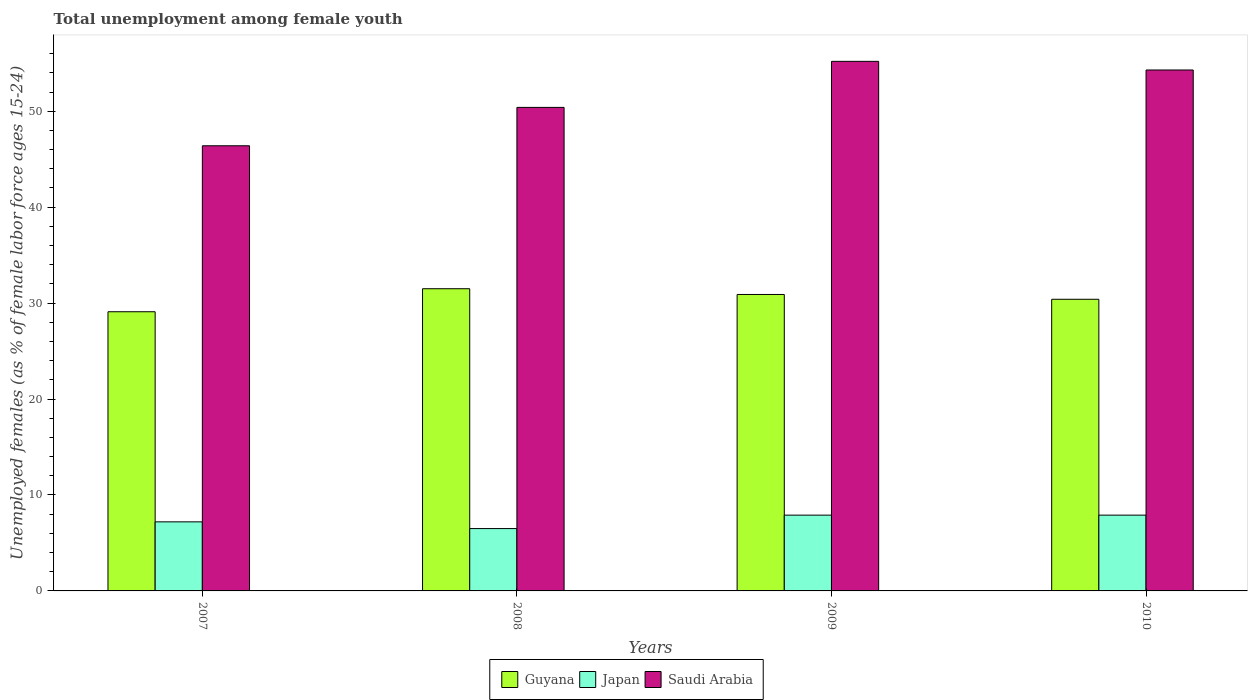How many different coloured bars are there?
Offer a very short reply. 3. How many groups of bars are there?
Make the answer very short. 4. Are the number of bars per tick equal to the number of legend labels?
Provide a short and direct response. Yes. Are the number of bars on each tick of the X-axis equal?
Your answer should be very brief. Yes. How many bars are there on the 2nd tick from the left?
Make the answer very short. 3. How many bars are there on the 4th tick from the right?
Provide a short and direct response. 3. What is the label of the 4th group of bars from the left?
Provide a succinct answer. 2010. In how many cases, is the number of bars for a given year not equal to the number of legend labels?
Offer a terse response. 0. What is the percentage of unemployed females in in Japan in 2010?
Make the answer very short. 7.9. Across all years, what is the maximum percentage of unemployed females in in Japan?
Offer a very short reply. 7.9. Across all years, what is the minimum percentage of unemployed females in in Japan?
Ensure brevity in your answer.  6.5. In which year was the percentage of unemployed females in in Japan maximum?
Provide a short and direct response. 2009. What is the total percentage of unemployed females in in Guyana in the graph?
Your response must be concise. 121.9. What is the difference between the percentage of unemployed females in in Guyana in 2007 and that in 2009?
Your answer should be compact. -1.8. What is the difference between the percentage of unemployed females in in Japan in 2008 and the percentage of unemployed females in in Guyana in 2009?
Keep it short and to the point. -24.4. What is the average percentage of unemployed females in in Saudi Arabia per year?
Provide a short and direct response. 51.58. In the year 2007, what is the difference between the percentage of unemployed females in in Saudi Arabia and percentage of unemployed females in in Japan?
Keep it short and to the point. 39.2. In how many years, is the percentage of unemployed females in in Japan greater than 42 %?
Your answer should be compact. 0. What is the ratio of the percentage of unemployed females in in Guyana in 2009 to that in 2010?
Your answer should be very brief. 1.02. Is the difference between the percentage of unemployed females in in Saudi Arabia in 2008 and 2010 greater than the difference between the percentage of unemployed females in in Japan in 2008 and 2010?
Your response must be concise. No. What is the difference between the highest and the second highest percentage of unemployed females in in Guyana?
Your answer should be very brief. 0.6. What is the difference between the highest and the lowest percentage of unemployed females in in Japan?
Your answer should be compact. 1.4. In how many years, is the percentage of unemployed females in in Saudi Arabia greater than the average percentage of unemployed females in in Saudi Arabia taken over all years?
Make the answer very short. 2. What does the 1st bar from the left in 2010 represents?
Provide a succinct answer. Guyana. What does the 1st bar from the right in 2007 represents?
Offer a very short reply. Saudi Arabia. Is it the case that in every year, the sum of the percentage of unemployed females in in Guyana and percentage of unemployed females in in Japan is greater than the percentage of unemployed females in in Saudi Arabia?
Your answer should be compact. No. How many years are there in the graph?
Ensure brevity in your answer.  4. What is the difference between two consecutive major ticks on the Y-axis?
Ensure brevity in your answer.  10. Are the values on the major ticks of Y-axis written in scientific E-notation?
Your answer should be compact. No. Does the graph contain any zero values?
Give a very brief answer. No. Does the graph contain grids?
Offer a very short reply. No. What is the title of the graph?
Offer a terse response. Total unemployment among female youth. Does "Jamaica" appear as one of the legend labels in the graph?
Make the answer very short. No. What is the label or title of the X-axis?
Provide a succinct answer. Years. What is the label or title of the Y-axis?
Offer a very short reply. Unemployed females (as % of female labor force ages 15-24). What is the Unemployed females (as % of female labor force ages 15-24) in Guyana in 2007?
Your answer should be compact. 29.1. What is the Unemployed females (as % of female labor force ages 15-24) in Japan in 2007?
Ensure brevity in your answer.  7.2. What is the Unemployed females (as % of female labor force ages 15-24) in Saudi Arabia in 2007?
Your response must be concise. 46.4. What is the Unemployed females (as % of female labor force ages 15-24) of Guyana in 2008?
Your answer should be compact. 31.5. What is the Unemployed females (as % of female labor force ages 15-24) of Saudi Arabia in 2008?
Make the answer very short. 50.4. What is the Unemployed females (as % of female labor force ages 15-24) of Guyana in 2009?
Keep it short and to the point. 30.9. What is the Unemployed females (as % of female labor force ages 15-24) of Japan in 2009?
Your answer should be very brief. 7.9. What is the Unemployed females (as % of female labor force ages 15-24) in Saudi Arabia in 2009?
Make the answer very short. 55.2. What is the Unemployed females (as % of female labor force ages 15-24) in Guyana in 2010?
Your answer should be compact. 30.4. What is the Unemployed females (as % of female labor force ages 15-24) in Japan in 2010?
Ensure brevity in your answer.  7.9. What is the Unemployed females (as % of female labor force ages 15-24) of Saudi Arabia in 2010?
Provide a short and direct response. 54.3. Across all years, what is the maximum Unemployed females (as % of female labor force ages 15-24) in Guyana?
Make the answer very short. 31.5. Across all years, what is the maximum Unemployed females (as % of female labor force ages 15-24) of Japan?
Your response must be concise. 7.9. Across all years, what is the maximum Unemployed females (as % of female labor force ages 15-24) in Saudi Arabia?
Keep it short and to the point. 55.2. Across all years, what is the minimum Unemployed females (as % of female labor force ages 15-24) in Guyana?
Offer a terse response. 29.1. Across all years, what is the minimum Unemployed females (as % of female labor force ages 15-24) in Japan?
Provide a succinct answer. 6.5. Across all years, what is the minimum Unemployed females (as % of female labor force ages 15-24) of Saudi Arabia?
Provide a succinct answer. 46.4. What is the total Unemployed females (as % of female labor force ages 15-24) in Guyana in the graph?
Your response must be concise. 121.9. What is the total Unemployed females (as % of female labor force ages 15-24) in Japan in the graph?
Your answer should be very brief. 29.5. What is the total Unemployed females (as % of female labor force ages 15-24) in Saudi Arabia in the graph?
Keep it short and to the point. 206.3. What is the difference between the Unemployed females (as % of female labor force ages 15-24) in Guyana in 2007 and that in 2008?
Your answer should be compact. -2.4. What is the difference between the Unemployed females (as % of female labor force ages 15-24) in Japan in 2007 and that in 2008?
Your response must be concise. 0.7. What is the difference between the Unemployed females (as % of female labor force ages 15-24) in Japan in 2007 and that in 2009?
Your response must be concise. -0.7. What is the difference between the Unemployed females (as % of female labor force ages 15-24) in Guyana in 2007 and that in 2010?
Your answer should be very brief. -1.3. What is the difference between the Unemployed females (as % of female labor force ages 15-24) in Guyana in 2008 and that in 2009?
Your response must be concise. 0.6. What is the difference between the Unemployed females (as % of female labor force ages 15-24) in Saudi Arabia in 2008 and that in 2009?
Offer a terse response. -4.8. What is the difference between the Unemployed females (as % of female labor force ages 15-24) of Guyana in 2008 and that in 2010?
Keep it short and to the point. 1.1. What is the difference between the Unemployed females (as % of female labor force ages 15-24) in Japan in 2008 and that in 2010?
Offer a very short reply. -1.4. What is the difference between the Unemployed females (as % of female labor force ages 15-24) of Japan in 2009 and that in 2010?
Give a very brief answer. 0. What is the difference between the Unemployed females (as % of female labor force ages 15-24) of Saudi Arabia in 2009 and that in 2010?
Provide a short and direct response. 0.9. What is the difference between the Unemployed females (as % of female labor force ages 15-24) in Guyana in 2007 and the Unemployed females (as % of female labor force ages 15-24) in Japan in 2008?
Provide a short and direct response. 22.6. What is the difference between the Unemployed females (as % of female labor force ages 15-24) of Guyana in 2007 and the Unemployed females (as % of female labor force ages 15-24) of Saudi Arabia in 2008?
Provide a short and direct response. -21.3. What is the difference between the Unemployed females (as % of female labor force ages 15-24) in Japan in 2007 and the Unemployed females (as % of female labor force ages 15-24) in Saudi Arabia in 2008?
Make the answer very short. -43.2. What is the difference between the Unemployed females (as % of female labor force ages 15-24) of Guyana in 2007 and the Unemployed females (as % of female labor force ages 15-24) of Japan in 2009?
Your response must be concise. 21.2. What is the difference between the Unemployed females (as % of female labor force ages 15-24) of Guyana in 2007 and the Unemployed females (as % of female labor force ages 15-24) of Saudi Arabia in 2009?
Make the answer very short. -26.1. What is the difference between the Unemployed females (as % of female labor force ages 15-24) in Japan in 2007 and the Unemployed females (as % of female labor force ages 15-24) in Saudi Arabia in 2009?
Give a very brief answer. -48. What is the difference between the Unemployed females (as % of female labor force ages 15-24) of Guyana in 2007 and the Unemployed females (as % of female labor force ages 15-24) of Japan in 2010?
Make the answer very short. 21.2. What is the difference between the Unemployed females (as % of female labor force ages 15-24) of Guyana in 2007 and the Unemployed females (as % of female labor force ages 15-24) of Saudi Arabia in 2010?
Provide a succinct answer. -25.2. What is the difference between the Unemployed females (as % of female labor force ages 15-24) in Japan in 2007 and the Unemployed females (as % of female labor force ages 15-24) in Saudi Arabia in 2010?
Offer a terse response. -47.1. What is the difference between the Unemployed females (as % of female labor force ages 15-24) of Guyana in 2008 and the Unemployed females (as % of female labor force ages 15-24) of Japan in 2009?
Ensure brevity in your answer.  23.6. What is the difference between the Unemployed females (as % of female labor force ages 15-24) of Guyana in 2008 and the Unemployed females (as % of female labor force ages 15-24) of Saudi Arabia in 2009?
Offer a terse response. -23.7. What is the difference between the Unemployed females (as % of female labor force ages 15-24) of Japan in 2008 and the Unemployed females (as % of female labor force ages 15-24) of Saudi Arabia in 2009?
Offer a very short reply. -48.7. What is the difference between the Unemployed females (as % of female labor force ages 15-24) in Guyana in 2008 and the Unemployed females (as % of female labor force ages 15-24) in Japan in 2010?
Make the answer very short. 23.6. What is the difference between the Unemployed females (as % of female labor force ages 15-24) of Guyana in 2008 and the Unemployed females (as % of female labor force ages 15-24) of Saudi Arabia in 2010?
Your answer should be compact. -22.8. What is the difference between the Unemployed females (as % of female labor force ages 15-24) in Japan in 2008 and the Unemployed females (as % of female labor force ages 15-24) in Saudi Arabia in 2010?
Your answer should be very brief. -47.8. What is the difference between the Unemployed females (as % of female labor force ages 15-24) of Guyana in 2009 and the Unemployed females (as % of female labor force ages 15-24) of Saudi Arabia in 2010?
Keep it short and to the point. -23.4. What is the difference between the Unemployed females (as % of female labor force ages 15-24) of Japan in 2009 and the Unemployed females (as % of female labor force ages 15-24) of Saudi Arabia in 2010?
Ensure brevity in your answer.  -46.4. What is the average Unemployed females (as % of female labor force ages 15-24) in Guyana per year?
Make the answer very short. 30.48. What is the average Unemployed females (as % of female labor force ages 15-24) in Japan per year?
Keep it short and to the point. 7.38. What is the average Unemployed females (as % of female labor force ages 15-24) of Saudi Arabia per year?
Your response must be concise. 51.58. In the year 2007, what is the difference between the Unemployed females (as % of female labor force ages 15-24) of Guyana and Unemployed females (as % of female labor force ages 15-24) of Japan?
Provide a short and direct response. 21.9. In the year 2007, what is the difference between the Unemployed females (as % of female labor force ages 15-24) of Guyana and Unemployed females (as % of female labor force ages 15-24) of Saudi Arabia?
Keep it short and to the point. -17.3. In the year 2007, what is the difference between the Unemployed females (as % of female labor force ages 15-24) in Japan and Unemployed females (as % of female labor force ages 15-24) in Saudi Arabia?
Your answer should be very brief. -39.2. In the year 2008, what is the difference between the Unemployed females (as % of female labor force ages 15-24) in Guyana and Unemployed females (as % of female labor force ages 15-24) in Japan?
Your response must be concise. 25. In the year 2008, what is the difference between the Unemployed females (as % of female labor force ages 15-24) of Guyana and Unemployed females (as % of female labor force ages 15-24) of Saudi Arabia?
Offer a terse response. -18.9. In the year 2008, what is the difference between the Unemployed females (as % of female labor force ages 15-24) of Japan and Unemployed females (as % of female labor force ages 15-24) of Saudi Arabia?
Your response must be concise. -43.9. In the year 2009, what is the difference between the Unemployed females (as % of female labor force ages 15-24) in Guyana and Unemployed females (as % of female labor force ages 15-24) in Japan?
Your answer should be very brief. 23. In the year 2009, what is the difference between the Unemployed females (as % of female labor force ages 15-24) of Guyana and Unemployed females (as % of female labor force ages 15-24) of Saudi Arabia?
Keep it short and to the point. -24.3. In the year 2009, what is the difference between the Unemployed females (as % of female labor force ages 15-24) of Japan and Unemployed females (as % of female labor force ages 15-24) of Saudi Arabia?
Ensure brevity in your answer.  -47.3. In the year 2010, what is the difference between the Unemployed females (as % of female labor force ages 15-24) in Guyana and Unemployed females (as % of female labor force ages 15-24) in Japan?
Keep it short and to the point. 22.5. In the year 2010, what is the difference between the Unemployed females (as % of female labor force ages 15-24) in Guyana and Unemployed females (as % of female labor force ages 15-24) in Saudi Arabia?
Your response must be concise. -23.9. In the year 2010, what is the difference between the Unemployed females (as % of female labor force ages 15-24) of Japan and Unemployed females (as % of female labor force ages 15-24) of Saudi Arabia?
Give a very brief answer. -46.4. What is the ratio of the Unemployed females (as % of female labor force ages 15-24) of Guyana in 2007 to that in 2008?
Your answer should be very brief. 0.92. What is the ratio of the Unemployed females (as % of female labor force ages 15-24) of Japan in 2007 to that in 2008?
Give a very brief answer. 1.11. What is the ratio of the Unemployed females (as % of female labor force ages 15-24) in Saudi Arabia in 2007 to that in 2008?
Ensure brevity in your answer.  0.92. What is the ratio of the Unemployed females (as % of female labor force ages 15-24) in Guyana in 2007 to that in 2009?
Ensure brevity in your answer.  0.94. What is the ratio of the Unemployed females (as % of female labor force ages 15-24) in Japan in 2007 to that in 2009?
Make the answer very short. 0.91. What is the ratio of the Unemployed females (as % of female labor force ages 15-24) in Saudi Arabia in 2007 to that in 2009?
Offer a terse response. 0.84. What is the ratio of the Unemployed females (as % of female labor force ages 15-24) of Guyana in 2007 to that in 2010?
Keep it short and to the point. 0.96. What is the ratio of the Unemployed females (as % of female labor force ages 15-24) of Japan in 2007 to that in 2010?
Provide a succinct answer. 0.91. What is the ratio of the Unemployed females (as % of female labor force ages 15-24) in Saudi Arabia in 2007 to that in 2010?
Offer a very short reply. 0.85. What is the ratio of the Unemployed females (as % of female labor force ages 15-24) in Guyana in 2008 to that in 2009?
Provide a succinct answer. 1.02. What is the ratio of the Unemployed females (as % of female labor force ages 15-24) of Japan in 2008 to that in 2009?
Your answer should be very brief. 0.82. What is the ratio of the Unemployed females (as % of female labor force ages 15-24) in Saudi Arabia in 2008 to that in 2009?
Your answer should be very brief. 0.91. What is the ratio of the Unemployed females (as % of female labor force ages 15-24) of Guyana in 2008 to that in 2010?
Your response must be concise. 1.04. What is the ratio of the Unemployed females (as % of female labor force ages 15-24) in Japan in 2008 to that in 2010?
Provide a short and direct response. 0.82. What is the ratio of the Unemployed females (as % of female labor force ages 15-24) in Saudi Arabia in 2008 to that in 2010?
Keep it short and to the point. 0.93. What is the ratio of the Unemployed females (as % of female labor force ages 15-24) of Guyana in 2009 to that in 2010?
Keep it short and to the point. 1.02. What is the ratio of the Unemployed females (as % of female labor force ages 15-24) of Japan in 2009 to that in 2010?
Keep it short and to the point. 1. What is the ratio of the Unemployed females (as % of female labor force ages 15-24) in Saudi Arabia in 2009 to that in 2010?
Provide a succinct answer. 1.02. What is the difference between the highest and the lowest Unemployed females (as % of female labor force ages 15-24) in Guyana?
Your answer should be compact. 2.4. What is the difference between the highest and the lowest Unemployed females (as % of female labor force ages 15-24) of Japan?
Give a very brief answer. 1.4. 